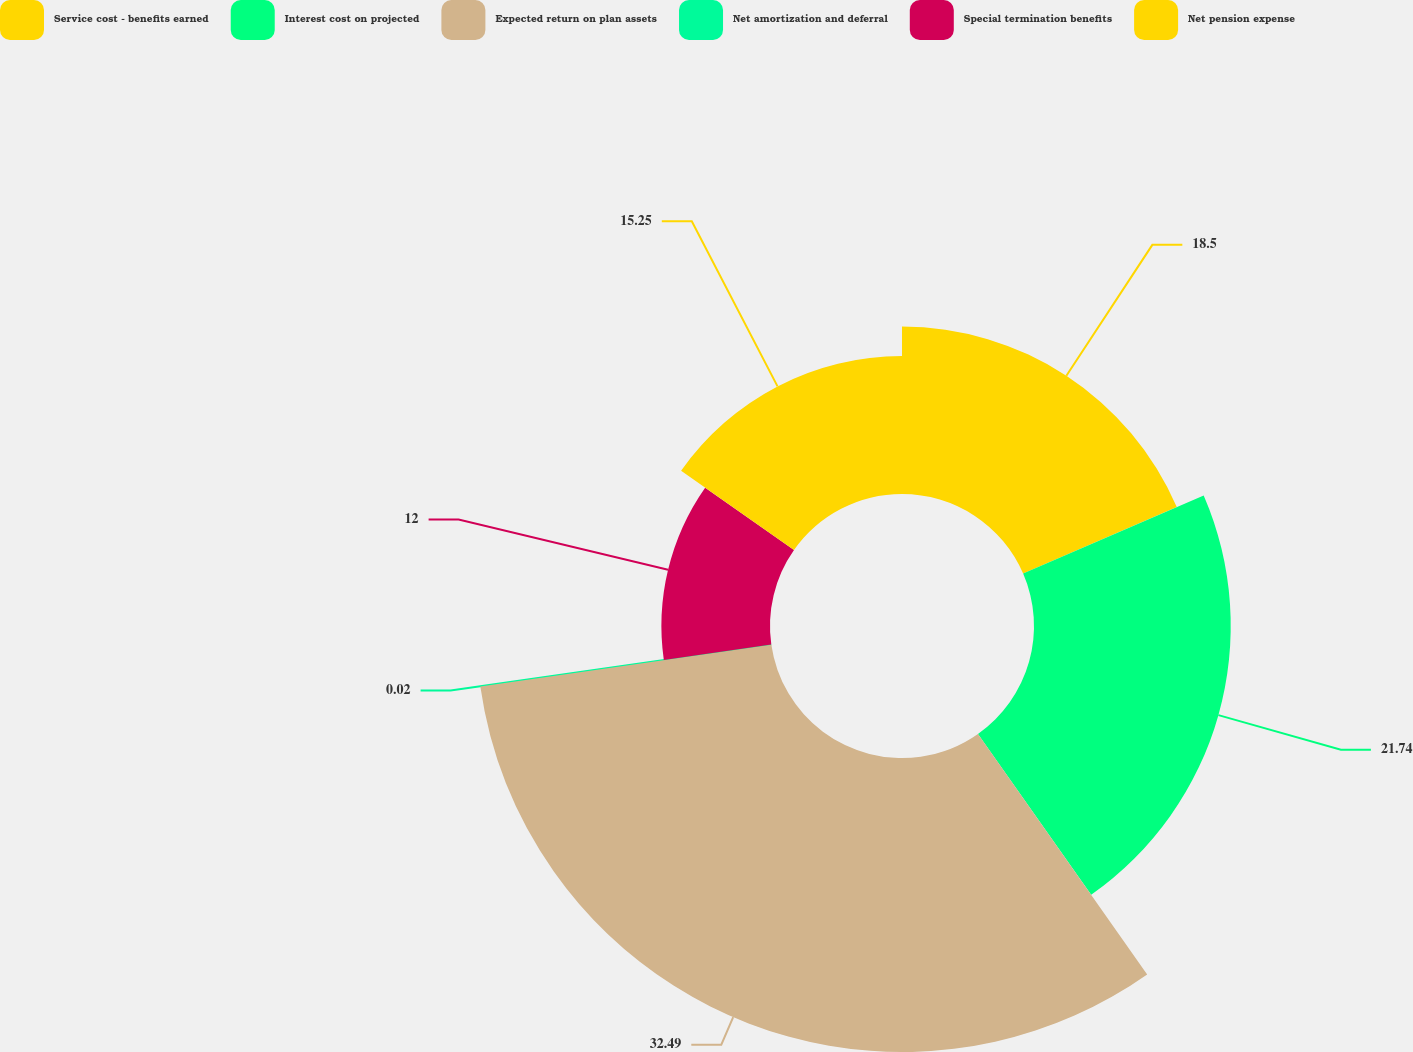<chart> <loc_0><loc_0><loc_500><loc_500><pie_chart><fcel>Service cost - benefits earned<fcel>Interest cost on projected<fcel>Expected return on plan assets<fcel>Net amortization and deferral<fcel>Special termination benefits<fcel>Net pension expense<nl><fcel>18.5%<fcel>21.74%<fcel>32.49%<fcel>0.02%<fcel>12.0%<fcel>15.25%<nl></chart> 